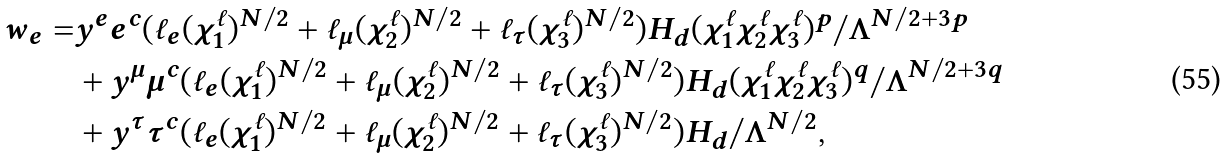<formula> <loc_0><loc_0><loc_500><loc_500>w _ { e } = & y ^ { e } e ^ { c } ( \ell _ { e } ( \chi _ { 1 } ^ { \ell } ) ^ { N / 2 } + \ell _ { \mu } ( \chi _ { 2 } ^ { \ell } ) ^ { N / 2 } + \ell _ { \tau } ( \chi _ { 3 } ^ { \ell } ) ^ { N / 2 } ) H _ { d } ( \chi _ { 1 } ^ { \ell } \chi _ { 2 } ^ { \ell } \chi _ { 3 } ^ { \ell } ) ^ { p } / \Lambda ^ { N / 2 + 3 p } \\ & + y ^ { \mu } \mu ^ { c } ( \ell _ { e } ( \chi _ { 1 } ^ { \ell } ) ^ { N / 2 } + \ell _ { \mu } ( \chi _ { 2 } ^ { \ell } ) ^ { N / 2 } + \ell _ { \tau } ( \chi _ { 3 } ^ { \ell } ) ^ { N / 2 } ) H _ { d } ( \chi _ { 1 } ^ { \ell } \chi _ { 2 } ^ { \ell } \chi _ { 3 } ^ { \ell } ) ^ { q } / \Lambda ^ { N / 2 + 3 q } \\ & + y ^ { \tau } \tau ^ { c } ( \ell _ { e } ( \chi _ { 1 } ^ { \ell } ) ^ { N / 2 } + \ell _ { \mu } ( \chi _ { 2 } ^ { \ell } ) ^ { N / 2 } + \ell _ { \tau } ( \chi _ { 3 } ^ { \ell } ) ^ { N / 2 } ) H _ { d } / \Lambda ^ { N / 2 } ,</formula> 